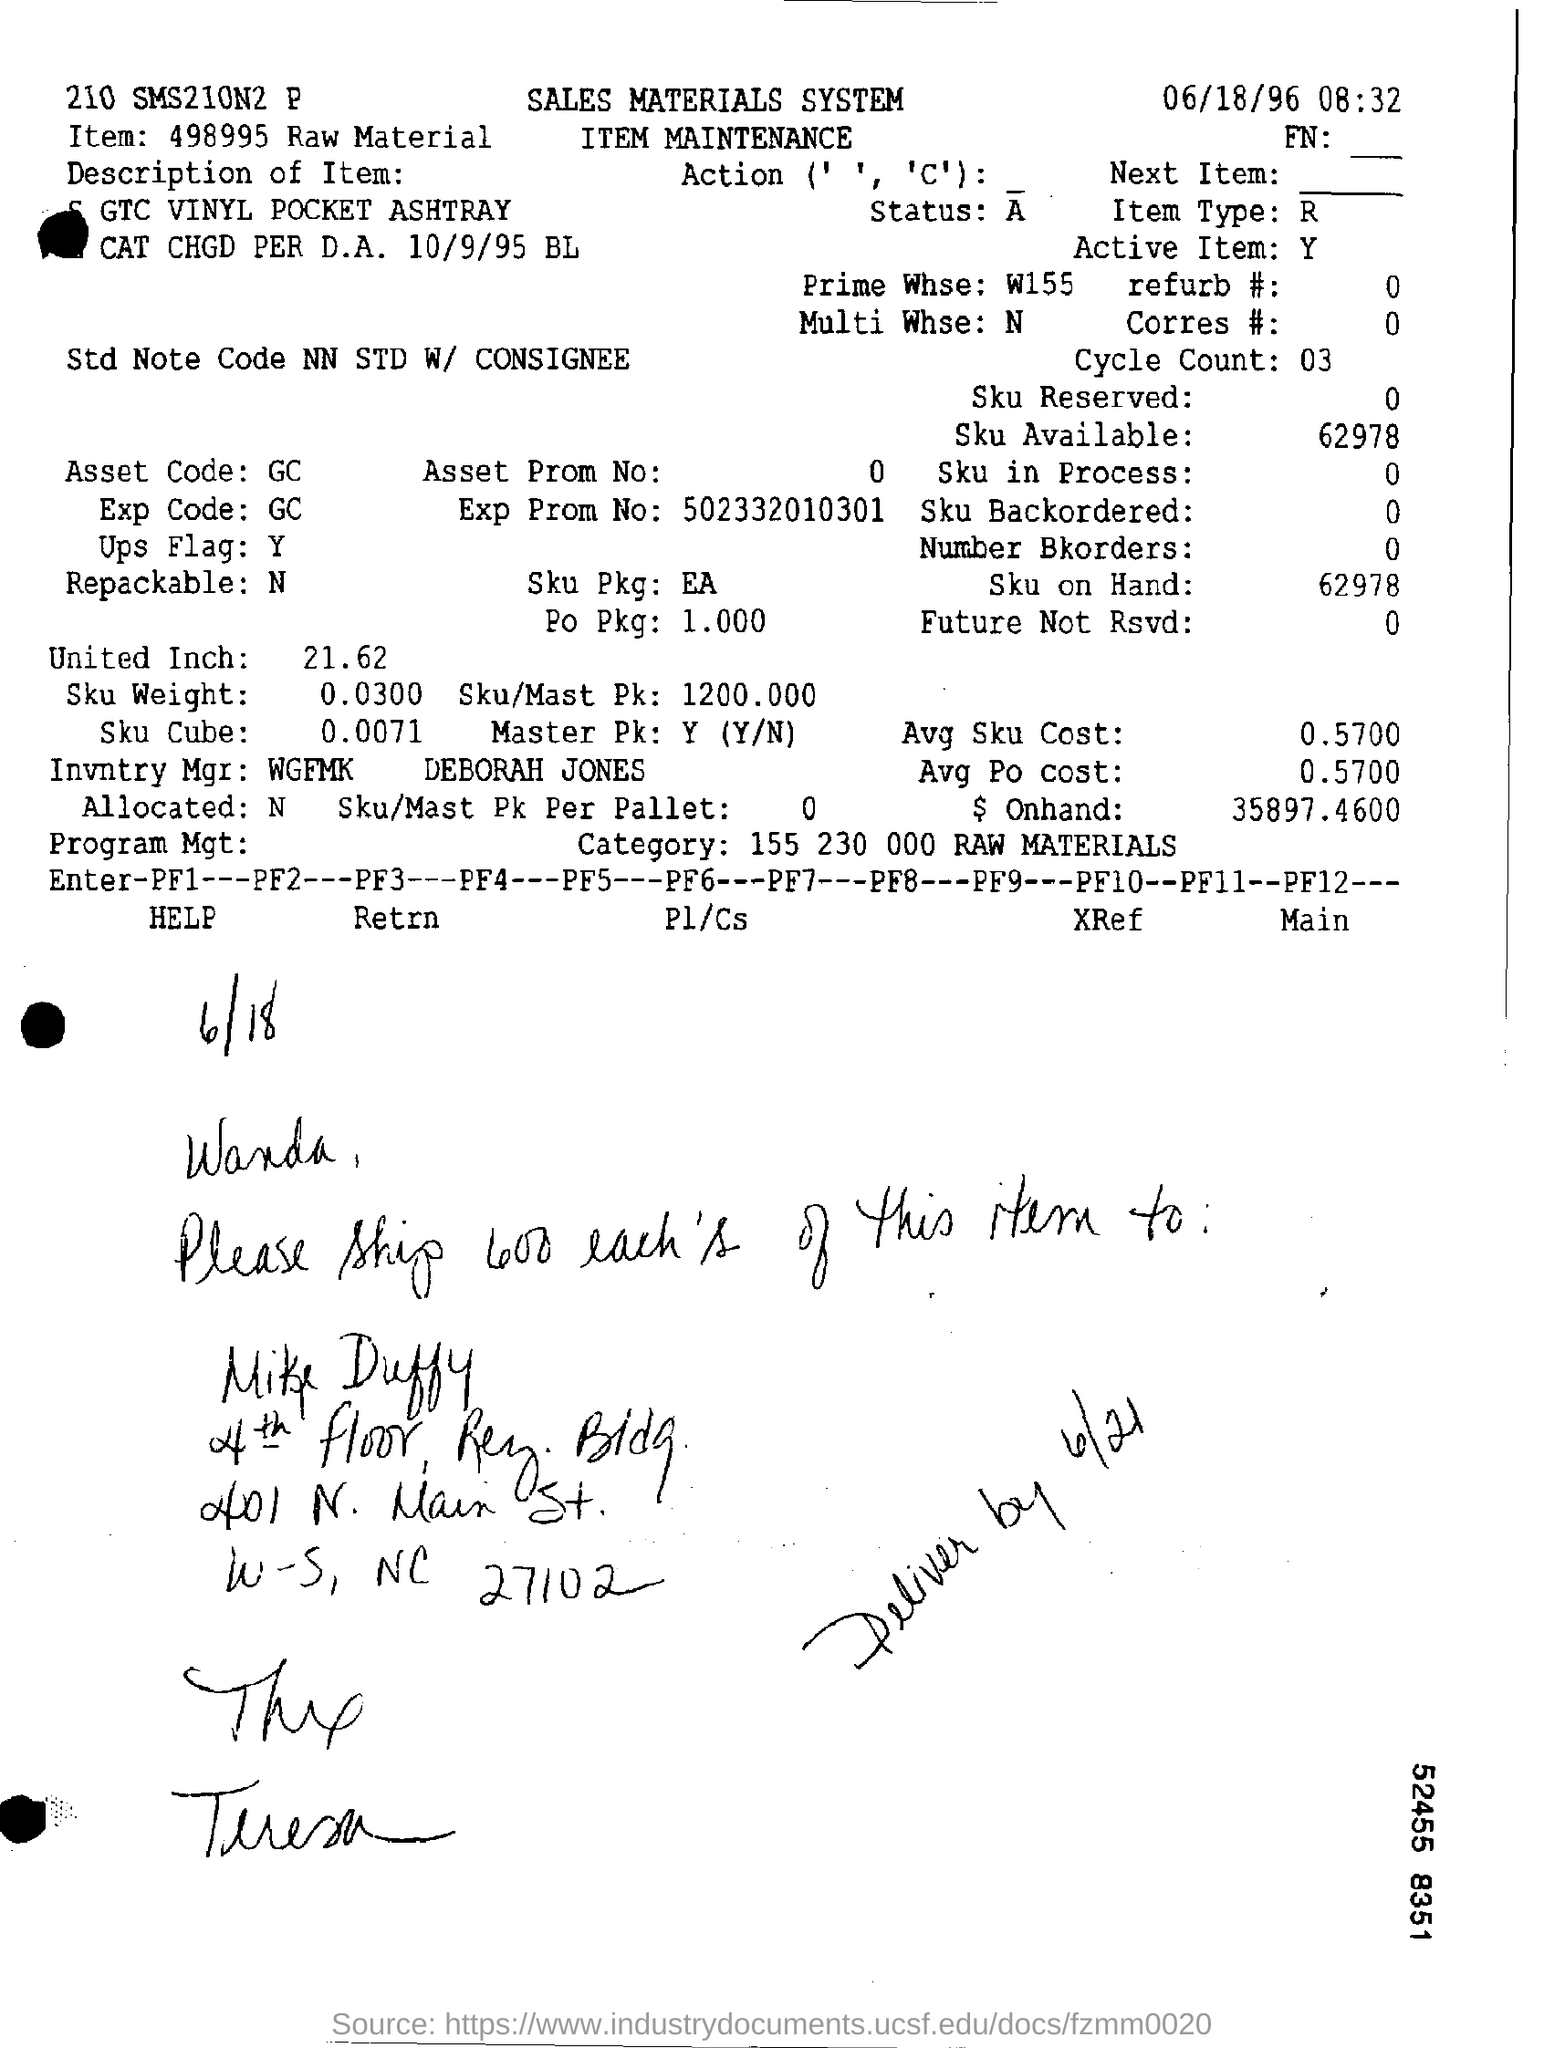What is the date mentioned in the top of the document ?
Your response must be concise. 06/18/96. What is written in the letter head ?
Keep it short and to the point. Sales materials system. What is written in the Item Field ?
Offer a terse response. 498995 raw material. What is mentioned in the EXP Code Field ?
Offer a very short reply. GC. What is written in the Item Type Field ?
Keep it short and to the point. R. What is the Exp Prom Number ?
Offer a terse response. 502332010301. What is mentioned in the Prime Whse Filed ?
Make the answer very short. W155. What is written in the Repackable  Field ?
Make the answer very short. N. What is mentioned in the Active Item Field ?
Your answer should be compact. Y. 